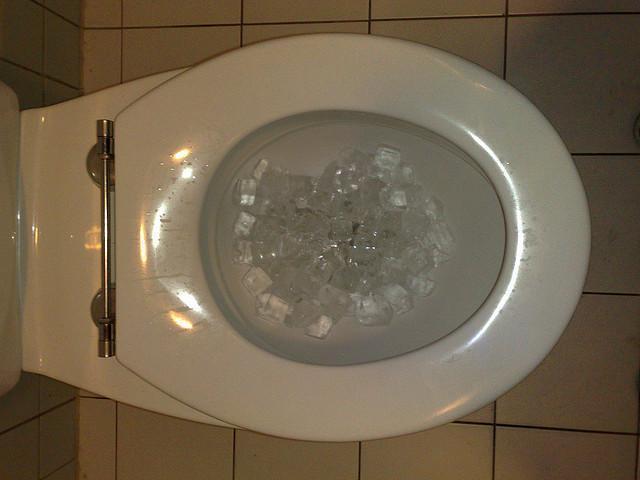How many people are wearing a red snow suit?
Give a very brief answer. 0. 